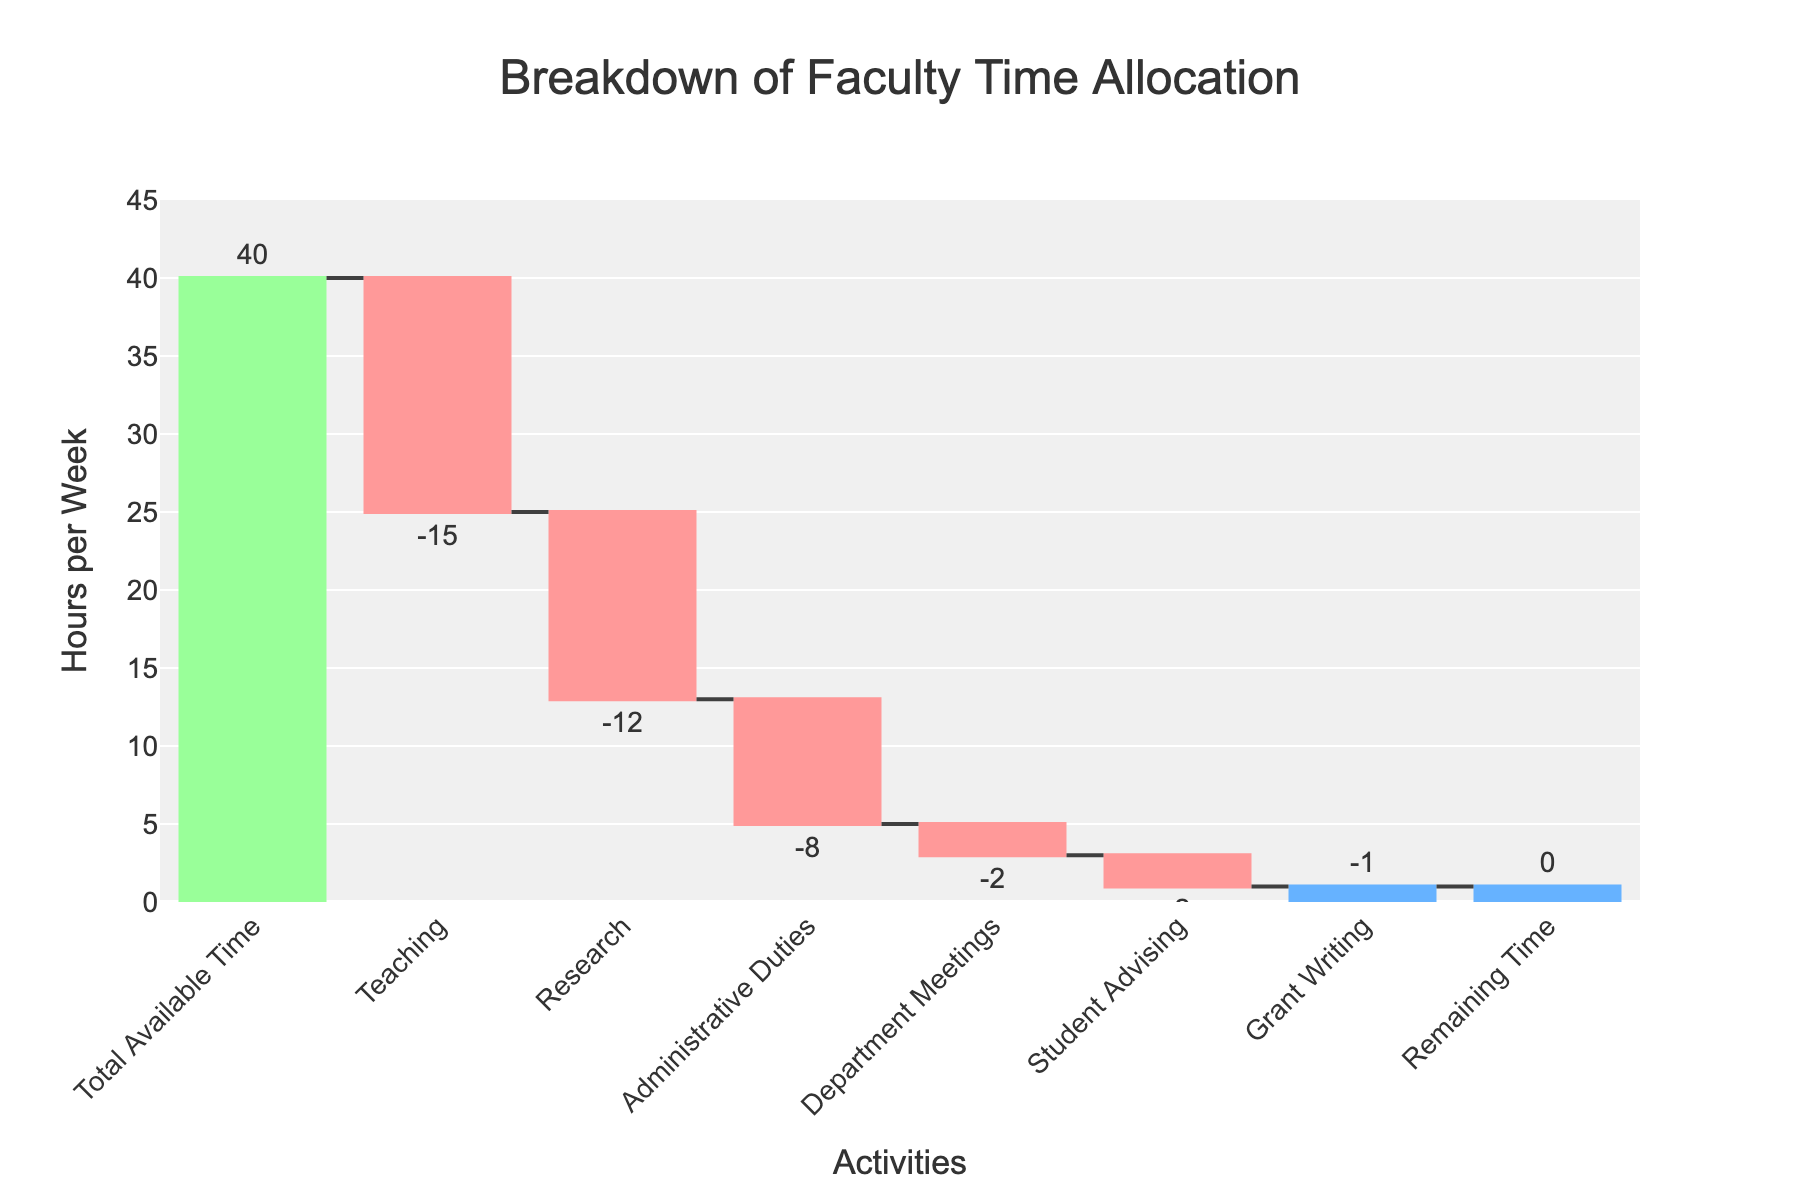What's the title of the chart? The title of the chart is displayed at the top of the figure. It reads "Breakdown of Faculty Time Allocation."
Answer: Breakdown of Faculty Time Allocation How many categories of activities are shown in the chart? The chart shows each category as a separate bar. By counting them, we see there are eight categories depicted in the waterfall chart.
Answer: Eight What is the total available time for the faculty? The total available time is indicated by the first bar in the chart, labeled "Total Available Time," which is 40 hours.
Answer: 40 hours How much time is allocated for teaching? The time allocated for teaching is shown as one of the bars in the chart and is labeled as -15 hours.
Answer: 15 hours Which activity has the least amount of allocated hours? Looking at the chart, the bar with the smallest magnitude is "Grant Writing," which has -1 hour.
Answer: Grant Writing What's the total time allocated to research and administrative duties combined? The time for research is -12 hours and for administrative duties is -8 hours. Adding these together gives -12 + (-8) = -20 hours.
Answer: 20 hours Compare the time allocated for teaching and research. Which one requires more time? Teaching has -15 hours and research has -12 hours. Since -15 is more negative than -12, teaching requires more time.
Answer: Teaching What is the remaining time after all activities? The remaining time is shown as the last bar in the chart, which is labeled "Remaining Time," and is 0 hours.
Answer: 0 hours How does the time allocated for student advising compare to department meetings? Student advising is -2 hours and department meetings are also -2 hours. Both have the same amount of allocated time.
Answer: Same amount If we combine the hours for department meetings, student advising, and grant writing, what is the total? Department meetings have -2 hours, student advising has -2 hours, and grant writing has -1 hour. Adding these together gives -2 + (-2) + (-1) = -5 hours.
Answer: 5 hours 